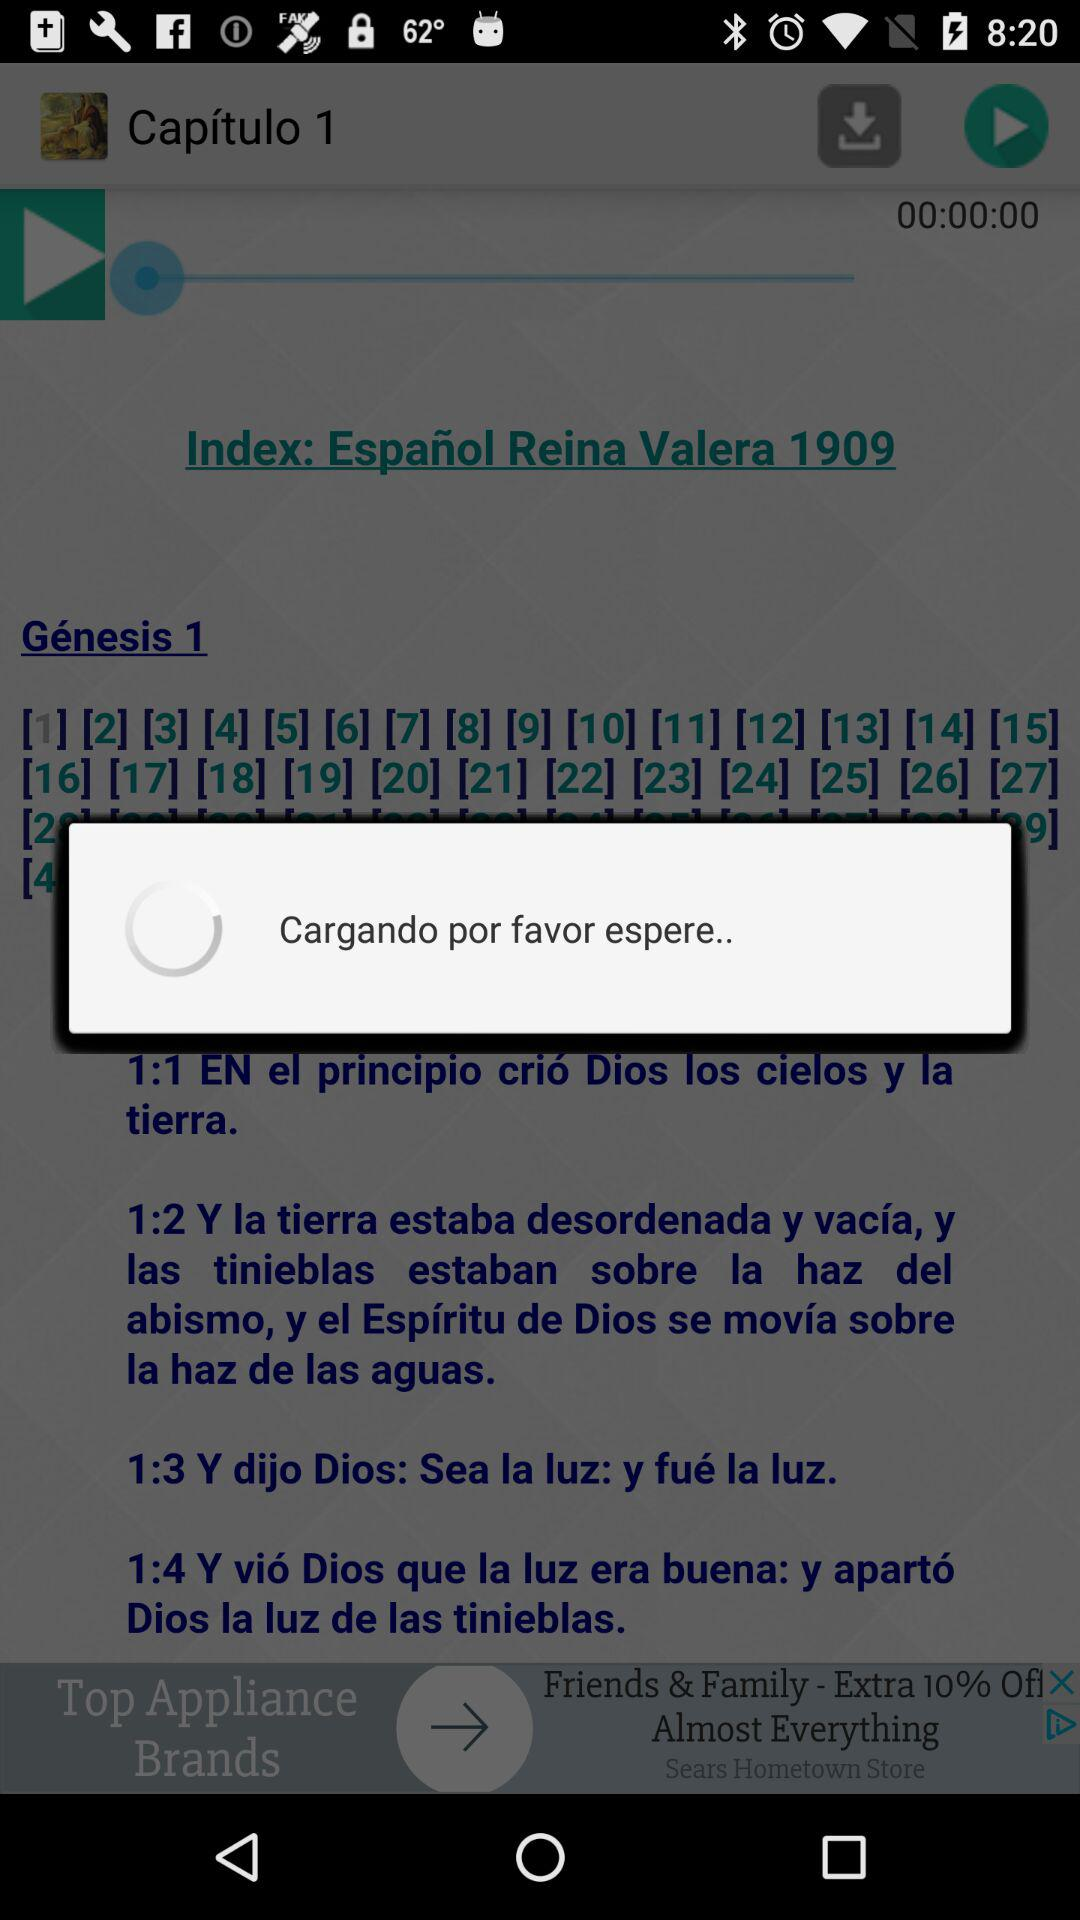How many hearts are there?
Answer the question using a single word or phrase. 2 